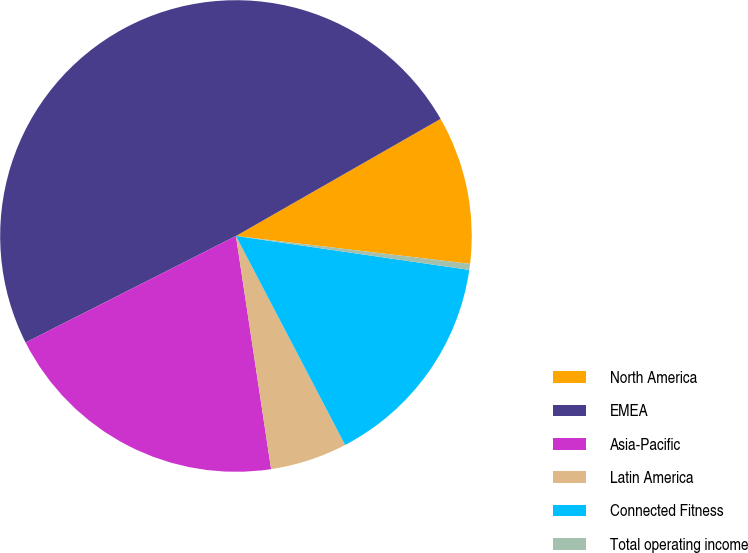Convert chart to OTSL. <chart><loc_0><loc_0><loc_500><loc_500><pie_chart><fcel>North America<fcel>EMEA<fcel>Asia-Pacific<fcel>Latin America<fcel>Connected Fitness<fcel>Total operating income<nl><fcel>10.16%<fcel>49.19%<fcel>19.92%<fcel>5.28%<fcel>15.04%<fcel>0.41%<nl></chart> 